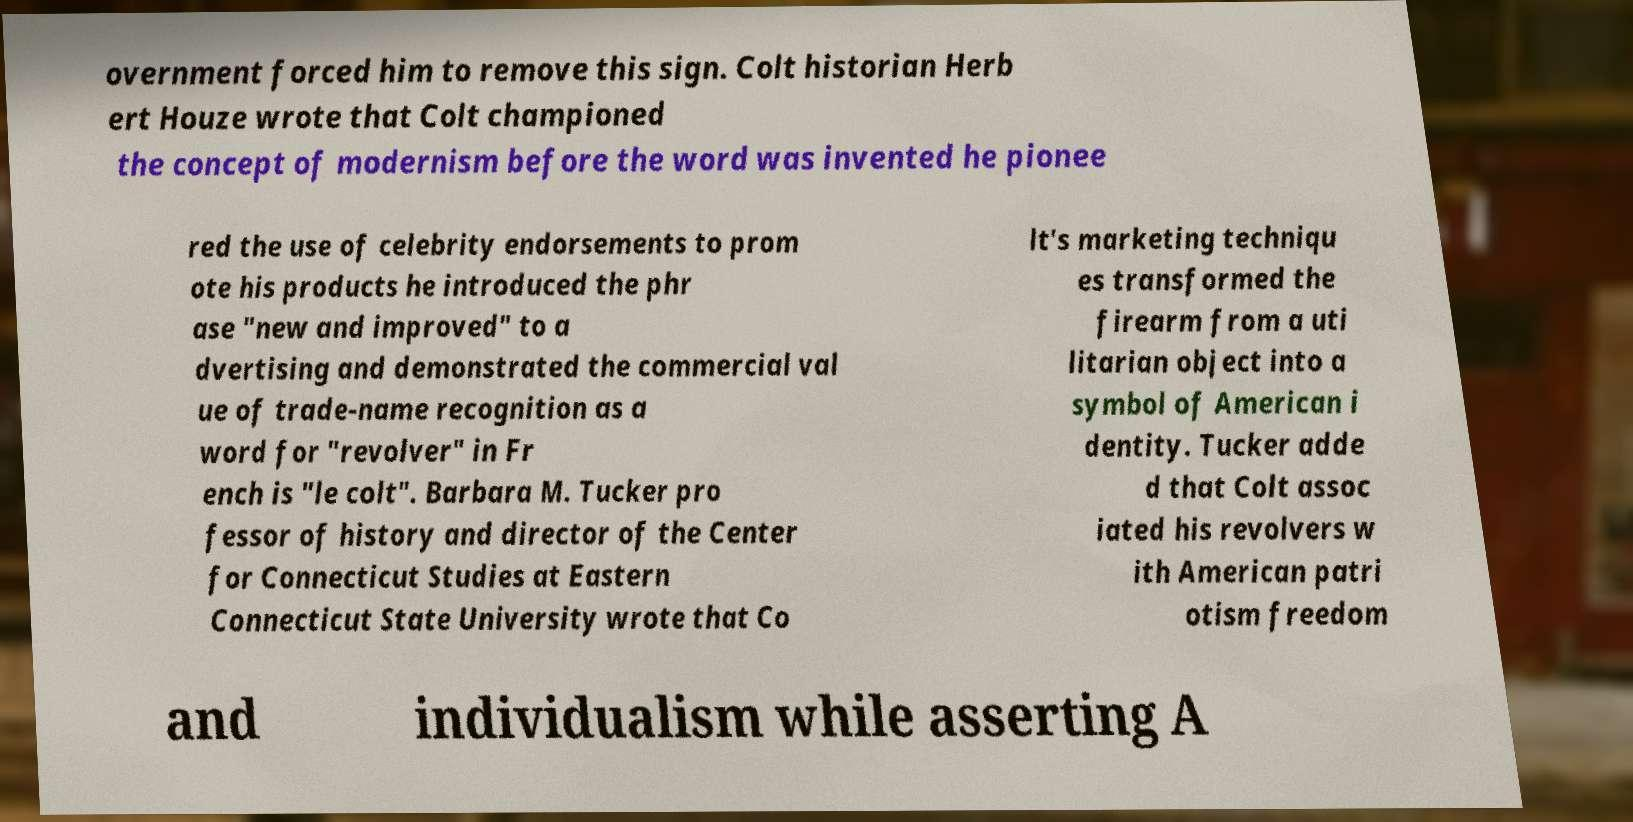Can you read and provide the text displayed in the image?This photo seems to have some interesting text. Can you extract and type it out for me? overnment forced him to remove this sign. Colt historian Herb ert Houze wrote that Colt championed the concept of modernism before the word was invented he pionee red the use of celebrity endorsements to prom ote his products he introduced the phr ase "new and improved" to a dvertising and demonstrated the commercial val ue of trade-name recognition as a word for "revolver" in Fr ench is "le colt". Barbara M. Tucker pro fessor of history and director of the Center for Connecticut Studies at Eastern Connecticut State University wrote that Co lt's marketing techniqu es transformed the firearm from a uti litarian object into a symbol of American i dentity. Tucker adde d that Colt assoc iated his revolvers w ith American patri otism freedom and individualism while asserting A 